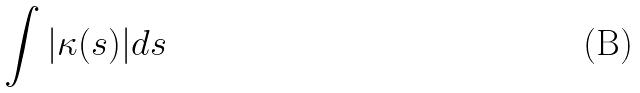Convert formula to latex. <formula><loc_0><loc_0><loc_500><loc_500>\int | \kappa ( s ) | d s</formula> 